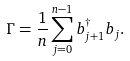Convert formula to latex. <formula><loc_0><loc_0><loc_500><loc_500>\Gamma = \frac { 1 } { n } \sum _ { j = 0 } ^ { n - 1 } b ^ { \dag } _ { j + 1 } b _ { j } .</formula> 